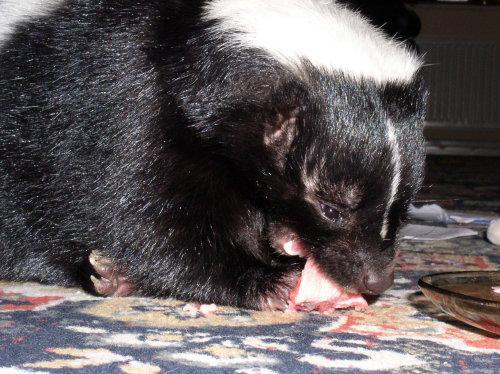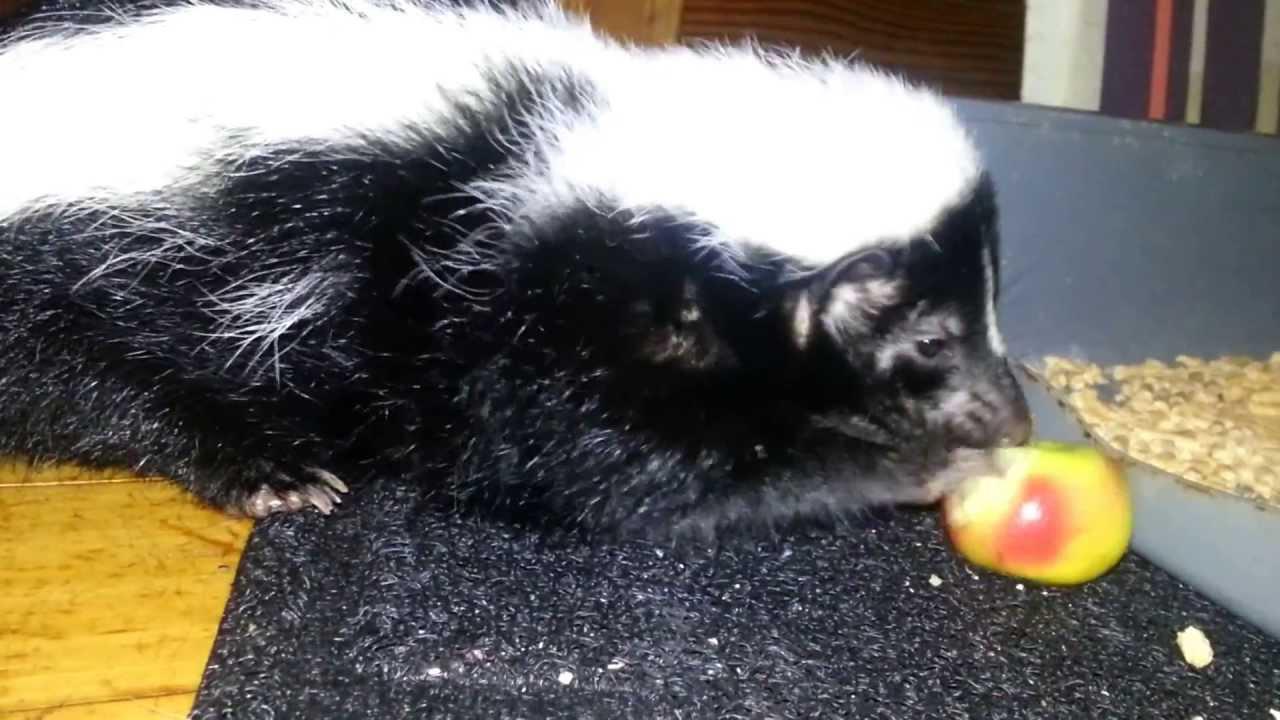The first image is the image on the left, the second image is the image on the right. Analyze the images presented: Is the assertion "There are only two skunks." valid? Answer yes or no. Yes. The first image is the image on the left, the second image is the image on the right. Considering the images on both sides, is "The right image shows one rightward-facing skunk with an oval food item in front of its nose." valid? Answer yes or no. Yes. 